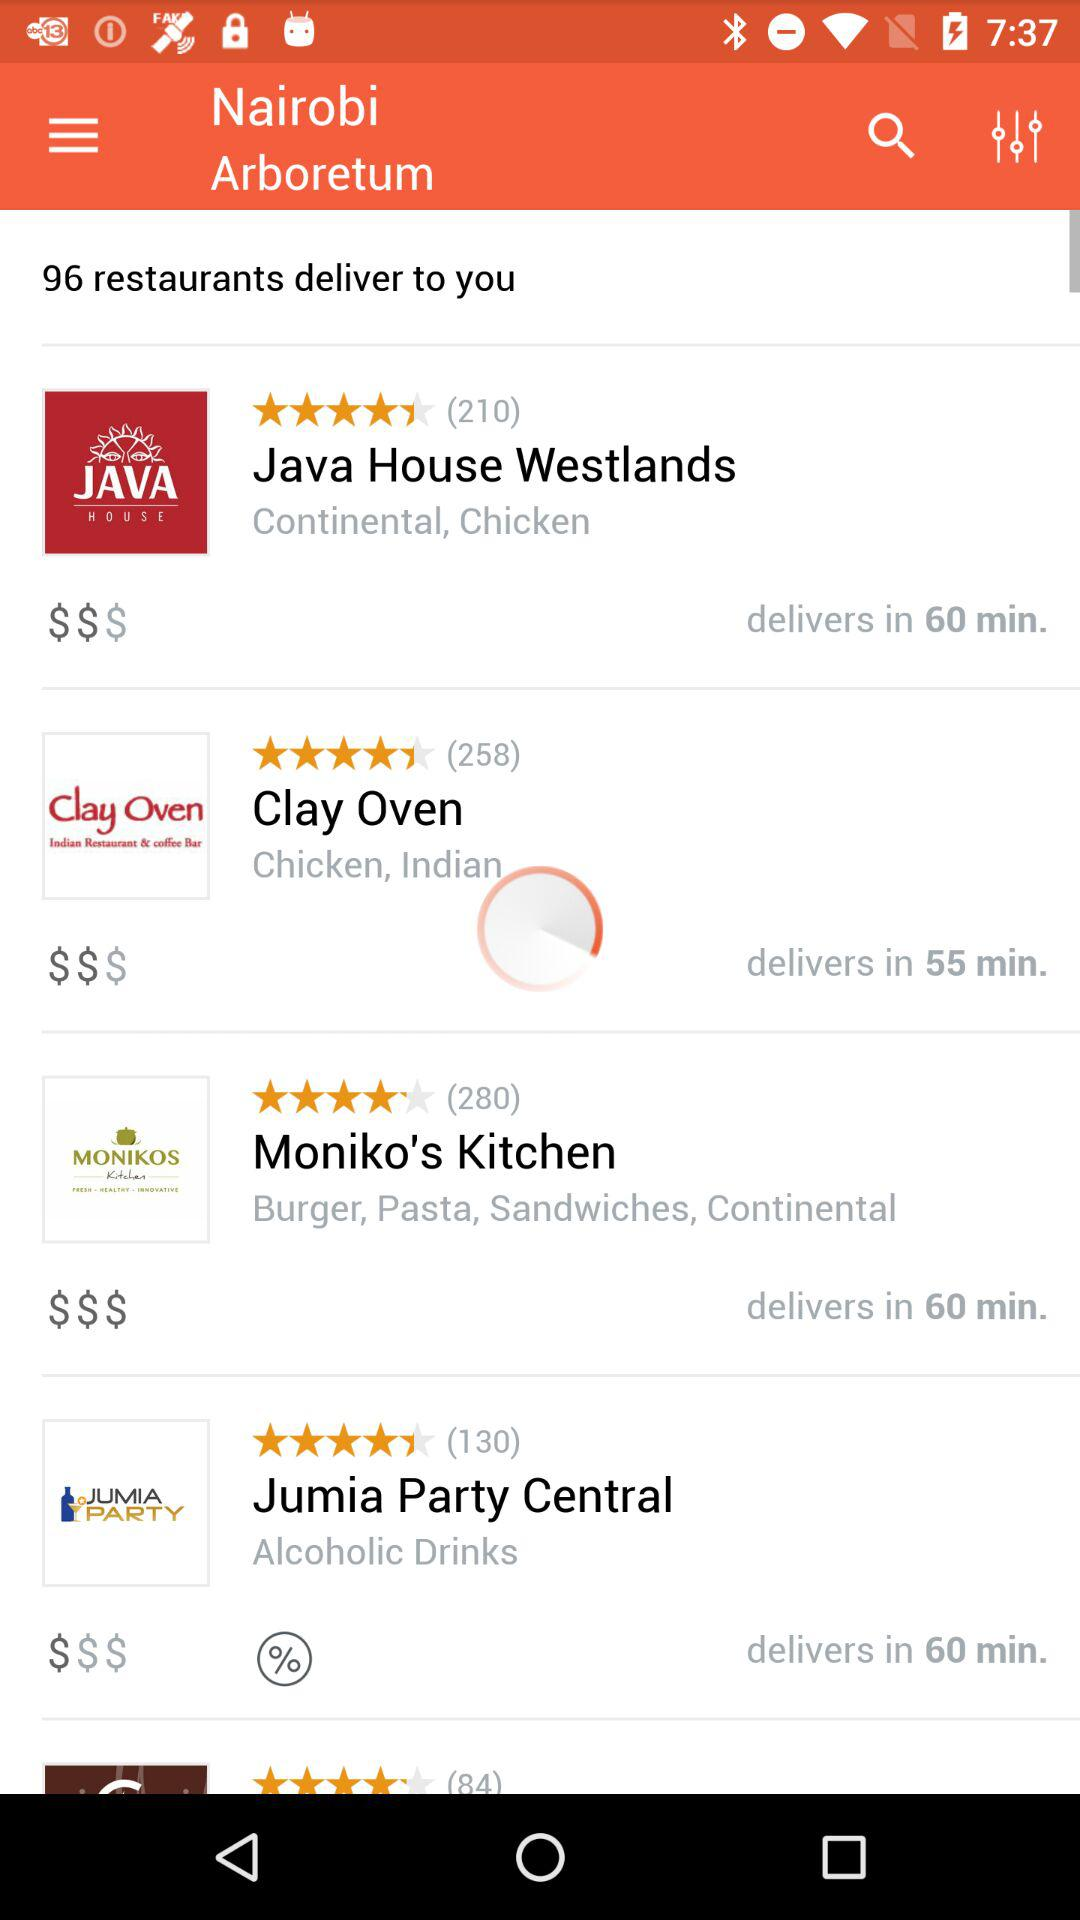How many restaurants deliver? There are 96 restaurants that deliver. 